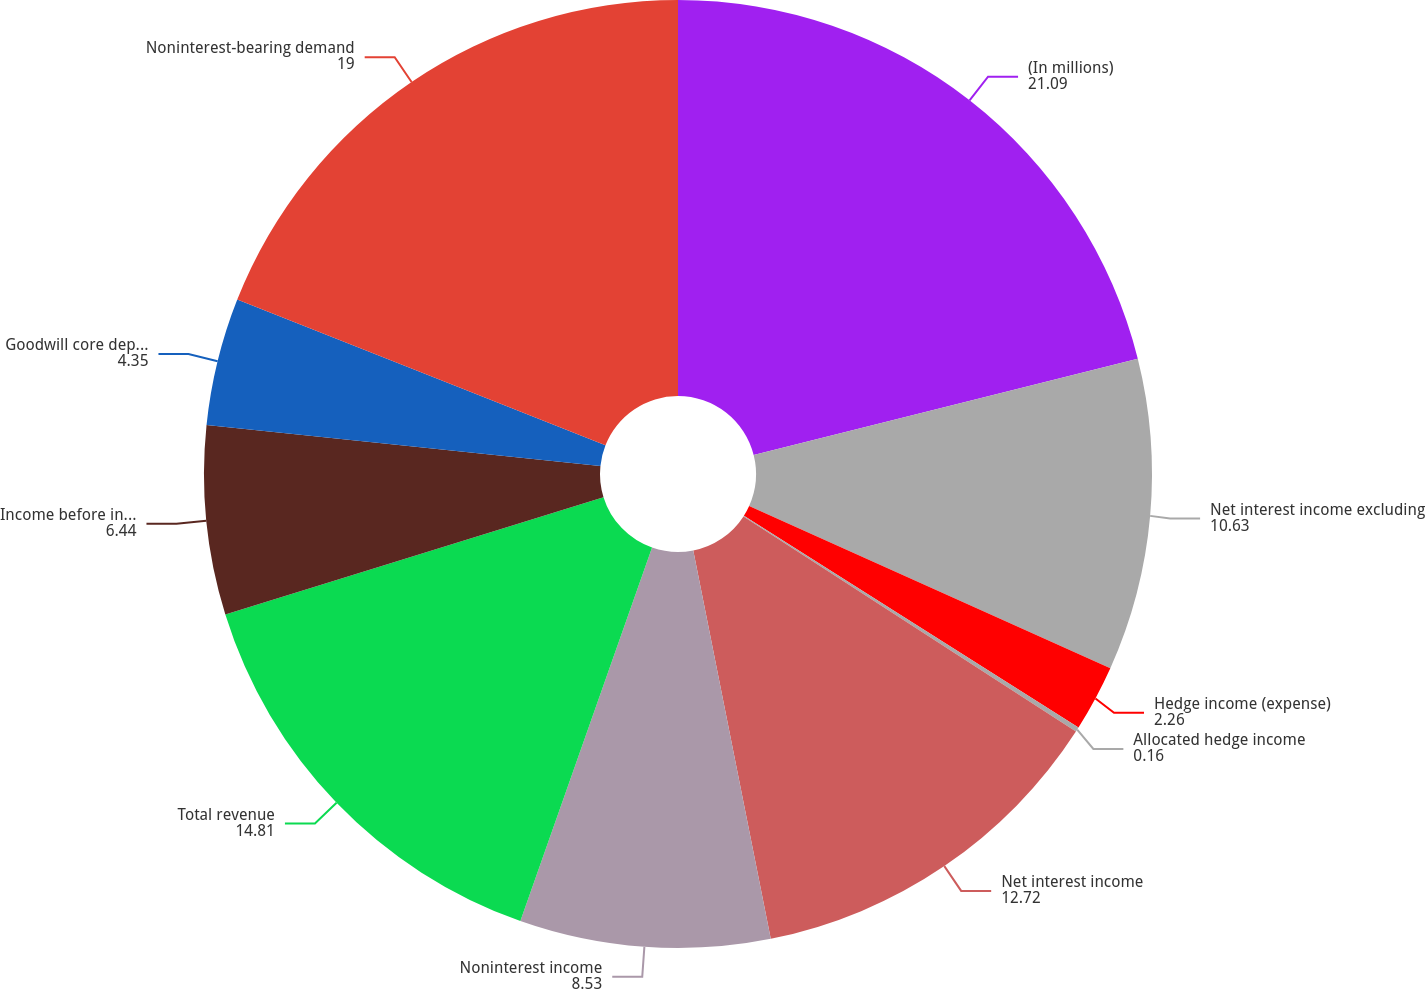Convert chart to OTSL. <chart><loc_0><loc_0><loc_500><loc_500><pie_chart><fcel>(In millions)<fcel>Net interest income excluding<fcel>Hedge income (expense)<fcel>Allocated hedge income<fcel>Net interest income<fcel>Noninterest income<fcel>Total revenue<fcel>Income before income taxes and<fcel>Goodwill core deposit and<fcel>Noninterest-bearing demand<nl><fcel>21.09%<fcel>10.63%<fcel>2.26%<fcel>0.16%<fcel>12.72%<fcel>8.53%<fcel>14.81%<fcel>6.44%<fcel>4.35%<fcel>19.0%<nl></chart> 